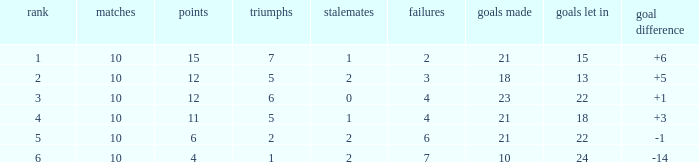Can you tell me the sum of Goals against that has the Goals for larger than 10, and the Position of 3, and the Wins smaller than 6? None. 